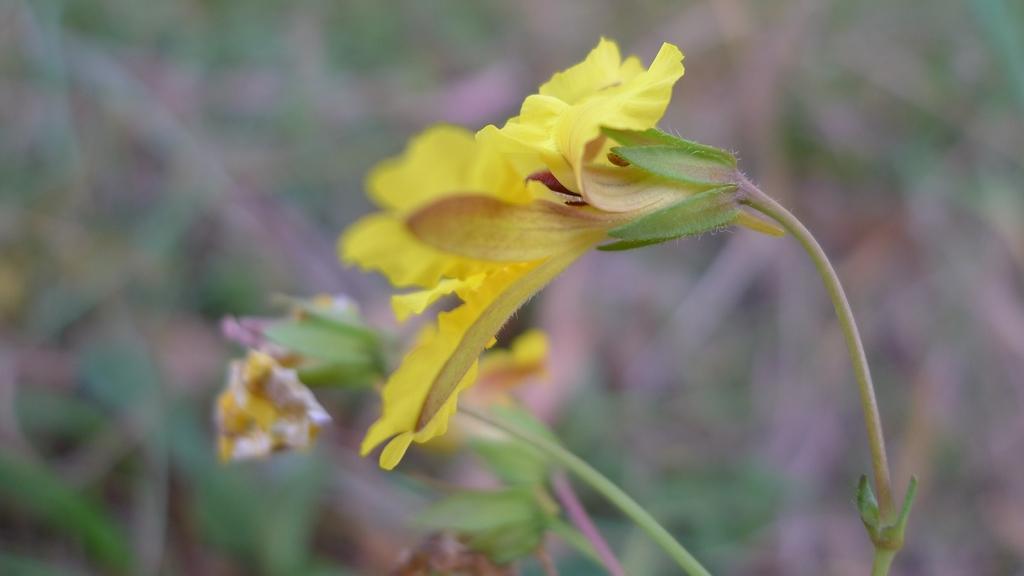In one or two sentences, can you explain what this image depicts? This image consists of a flower in yellow color. In the background, we can see the plants. And the background is blurred. 